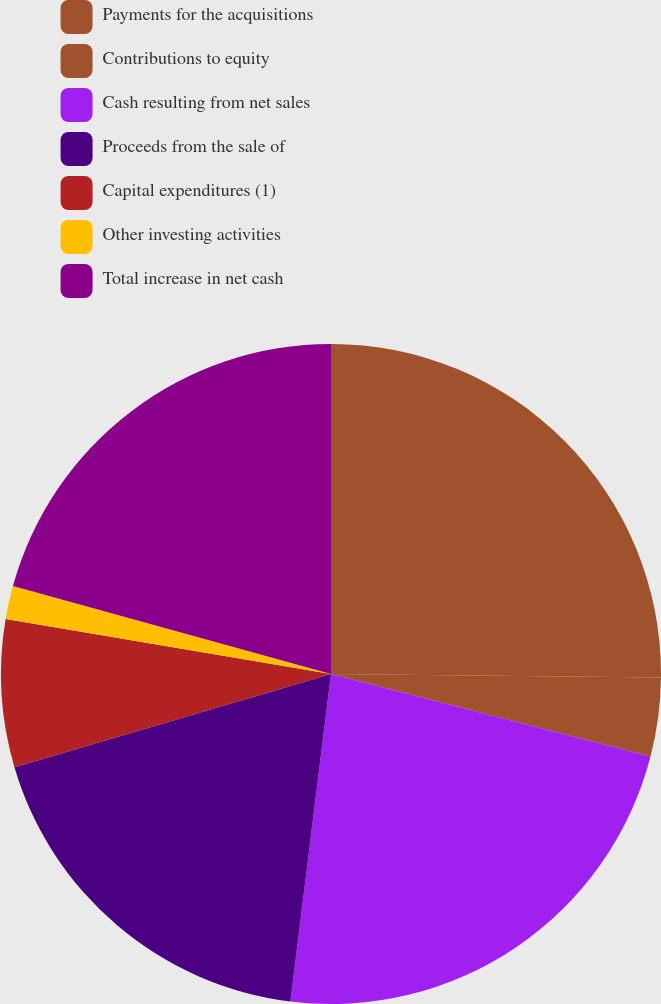Convert chart to OTSL. <chart><loc_0><loc_0><loc_500><loc_500><pie_chart><fcel>Payments for the acquisitions<fcel>Contributions to equity<fcel>Cash resulting from net sales<fcel>Proceeds from the sale of<fcel>Capital expenditures (1)<fcel>Other investing activities<fcel>Total increase in net cash<nl><fcel>25.17%<fcel>3.86%<fcel>22.94%<fcel>18.48%<fcel>7.22%<fcel>1.63%<fcel>20.71%<nl></chart> 